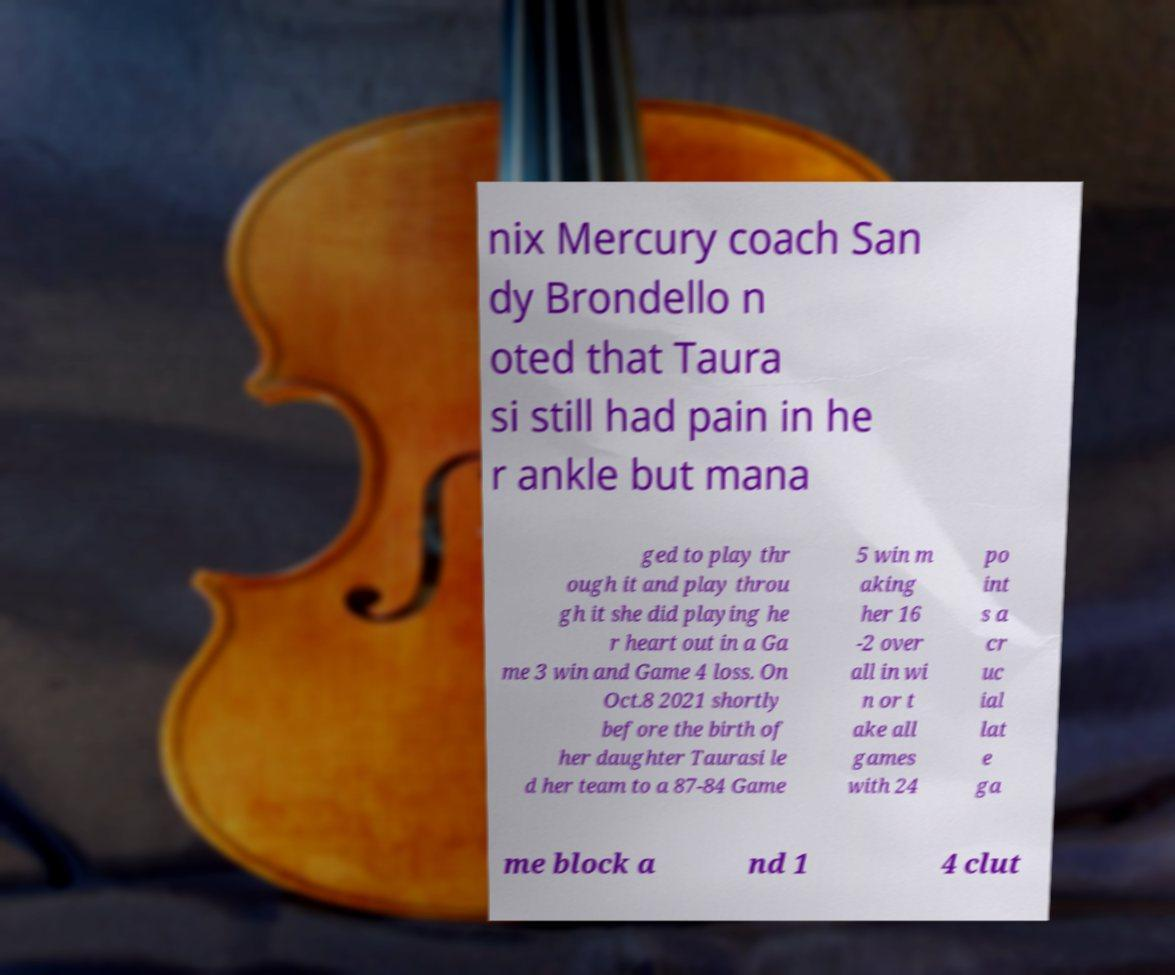Can you read and provide the text displayed in the image?This photo seems to have some interesting text. Can you extract and type it out for me? nix Mercury coach San dy Brondello n oted that Taura si still had pain in he r ankle but mana ged to play thr ough it and play throu gh it she did playing he r heart out in a Ga me 3 win and Game 4 loss. On Oct.8 2021 shortly before the birth of her daughter Taurasi le d her team to a 87-84 Game 5 win m aking her 16 -2 over all in wi n or t ake all games with 24 po int s a cr uc ial lat e ga me block a nd 1 4 clut 